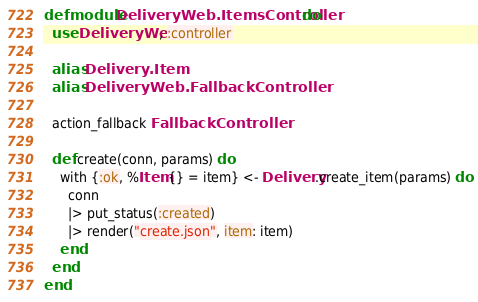<code> <loc_0><loc_0><loc_500><loc_500><_Elixir_>defmodule DeliveryWeb.ItemsController do
  use DeliveryWeb, :controller

  alias Delivery.Item
  alias DeliveryWeb.FallbackController

  action_fallback FallbackController

  def create(conn, params) do
    with {:ok, %Item{} = item} <- Delivery.create_item(params) do
      conn
      |> put_status(:created)
      |> render("create.json", item: item)
    end
  end
end
</code> 